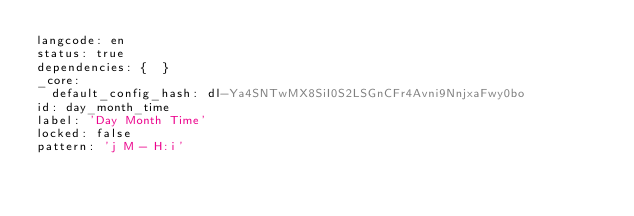Convert code to text. <code><loc_0><loc_0><loc_500><loc_500><_YAML_>langcode: en
status: true
dependencies: {  }
_core:
  default_config_hash: dl-Ya4SNTwMX8SiI0S2LSGnCFr4Avni9NnjxaFwy0bo
id: day_month_time
label: 'Day Month Time'
locked: false
pattern: 'j M - H:i'
</code> 